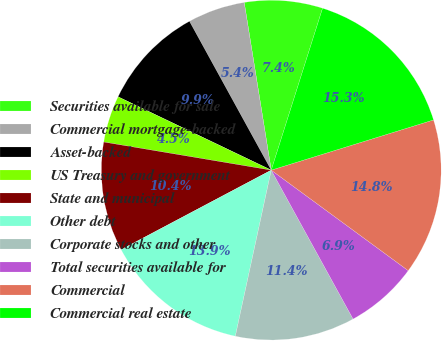Convert chart to OTSL. <chart><loc_0><loc_0><loc_500><loc_500><pie_chart><fcel>Securities available for sale<fcel>Commercial mortgage-backed<fcel>Asset-backed<fcel>US Treasury and government<fcel>State and municipal<fcel>Other debt<fcel>Corporate stocks and other<fcel>Total securities available for<fcel>Commercial<fcel>Commercial real estate<nl><fcel>7.43%<fcel>5.45%<fcel>9.9%<fcel>4.46%<fcel>10.4%<fcel>13.86%<fcel>11.39%<fcel>6.93%<fcel>14.85%<fcel>15.34%<nl></chart> 